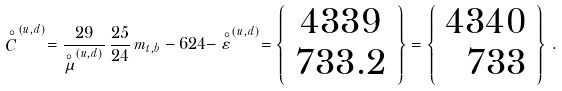Convert formula to latex. <formula><loc_0><loc_0><loc_500><loc_500>\stackrel { \circ } { C } ^ { ( u , d ) } = \frac { 2 9 } { \stackrel { \circ } { \mu } ^ { ( u , d ) } } \, \frac { 2 5 } { 2 4 } \, m _ { t , b } - 6 2 4 - \stackrel { \circ } { \varepsilon } ^ { ( u , d ) } = \left \{ \begin{array} { c } 4 3 3 9 \\ 7 3 3 . 2 \end{array} \right \} = \left \{ \begin{array} { r } 4 3 4 0 \\ 7 3 3 \end{array} \right \} \, .</formula> 